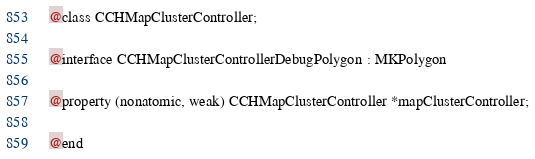Convert code to text. <code><loc_0><loc_0><loc_500><loc_500><_C_>
@class CCHMapClusterController;

@interface CCHMapClusterControllerDebugPolygon : MKPolygon

@property (nonatomic, weak) CCHMapClusterController *mapClusterController;

@end
</code> 